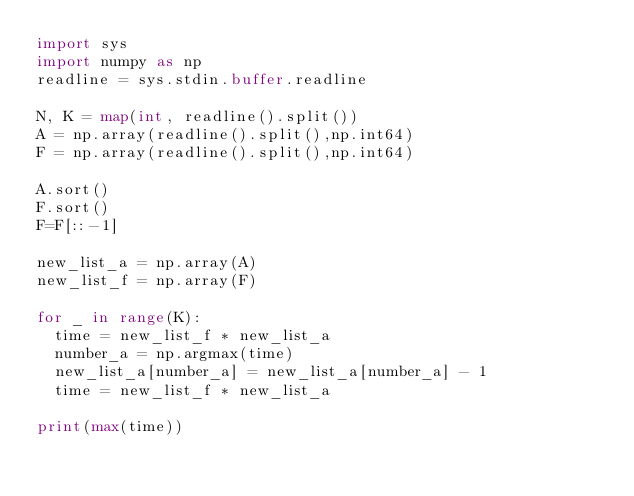Convert code to text. <code><loc_0><loc_0><loc_500><loc_500><_Python_>import sys
import numpy as np
readline = sys.stdin.buffer.readline

N, K = map(int, readline().split())
A = np.array(readline().split(),np.int64)
F = np.array(readline().split(),np.int64)

A.sort()
F.sort()
F=F[::-1]
 
new_list_a = np.array(A)
new_list_f = np.array(F)
 
for _ in range(K):
  time = new_list_f * new_list_a
  number_a = np.argmax(time)
  new_list_a[number_a] = new_list_a[number_a] - 1
  time = new_list_f * new_list_a
  
print(max(time))</code> 